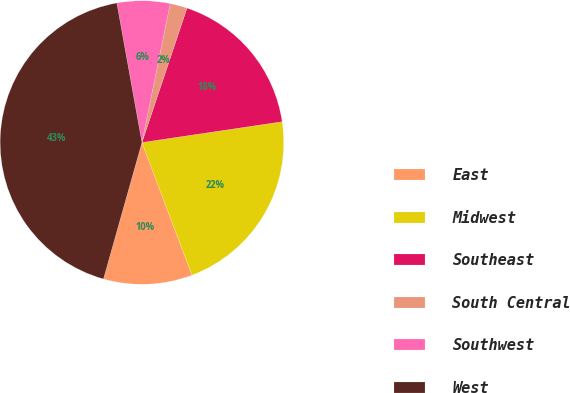<chart> <loc_0><loc_0><loc_500><loc_500><pie_chart><fcel>East<fcel>Midwest<fcel>Southeast<fcel>South Central<fcel>Southwest<fcel>West<nl><fcel>10.12%<fcel>21.6%<fcel>17.51%<fcel>1.95%<fcel>6.03%<fcel>42.8%<nl></chart> 